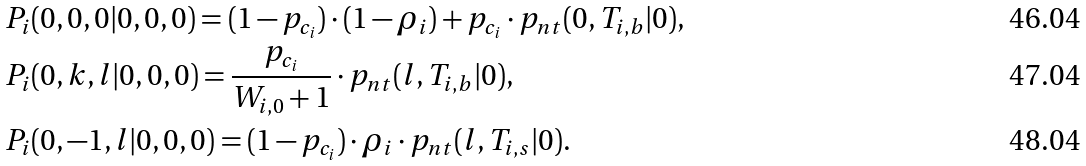<formula> <loc_0><loc_0><loc_500><loc_500>& P _ { i } ( 0 , 0 , 0 | 0 , 0 , 0 ) = ( 1 - p _ { c _ { i } } ) \cdot ( 1 - \rho _ { i } ) + p _ { c _ { i } } \cdot p _ { n t } ( 0 , T _ { i , b } | 0 ) , \\ & P _ { i } ( 0 , k , l | 0 , 0 , 0 ) = \frac { p _ { c _ { i } } } { W _ { i , 0 } + 1 } \cdot p _ { n t } ( l , T _ { i , b } | 0 ) , \\ & P _ { i } ( 0 , - 1 , l | 0 , 0 , 0 ) = ( 1 - p _ { c _ { i } } ) \cdot \rho _ { i } \cdot p _ { n t } ( l , T _ { i , s } | 0 ) .</formula> 